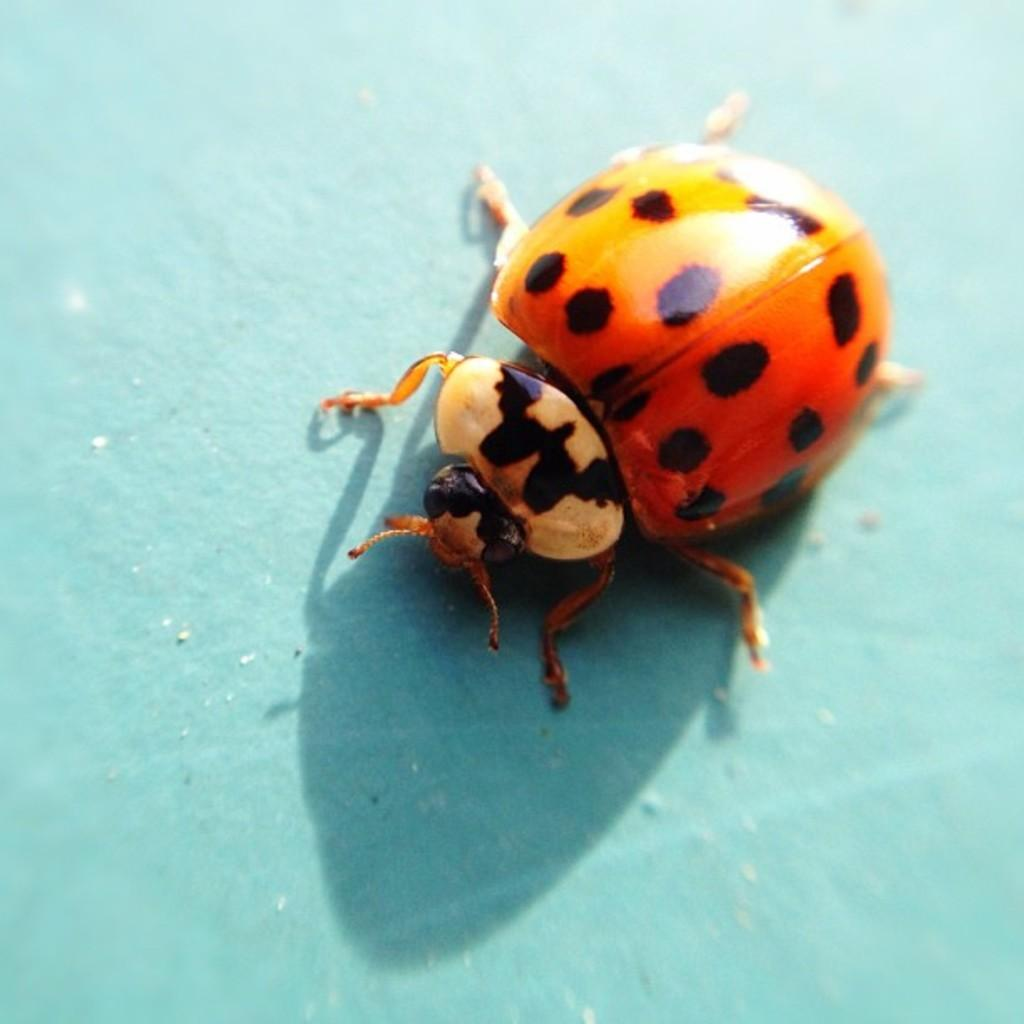What type of creature is in the image? There is an insect in the image. What colors can be seen on the insect? The insect has black and orange colors. What is the insect resting on in the image? The insect is on a blue surface. What type of balloon is floating above the insect in the image? There is no balloon present in the image. What achievements has the insect accomplished, as seen in the image? The image does not provide information about the insect's achievements. 